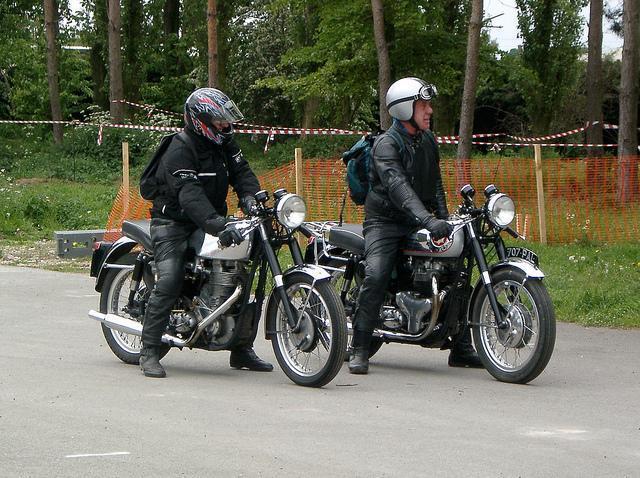How many motorcycles are there?
Give a very brief answer. 2. How many people are there?
Give a very brief answer. 2. 